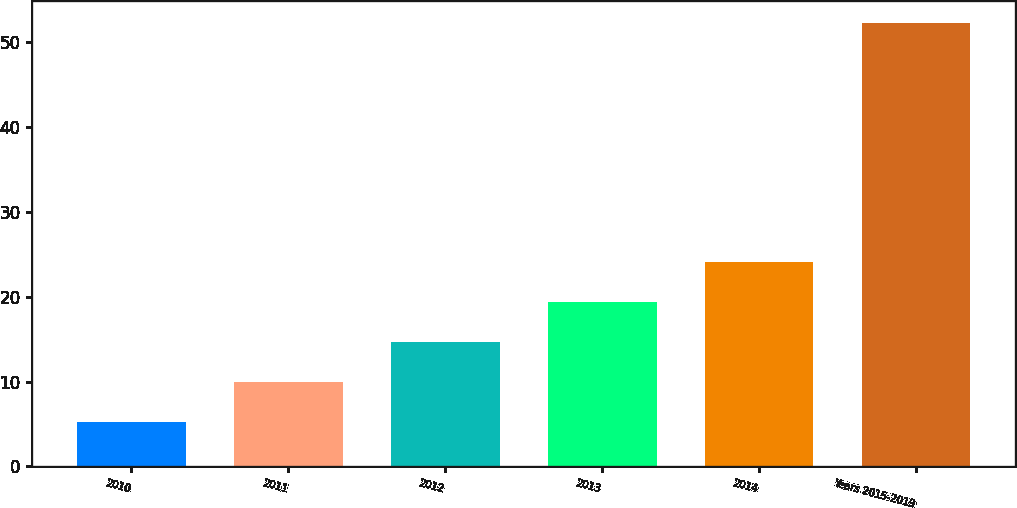Convert chart. <chart><loc_0><loc_0><loc_500><loc_500><bar_chart><fcel>2010<fcel>2011<fcel>2012<fcel>2013<fcel>2014<fcel>Years 2015-2019<nl><fcel>5.2<fcel>9.91<fcel>14.62<fcel>19.33<fcel>24.04<fcel>52.3<nl></chart> 